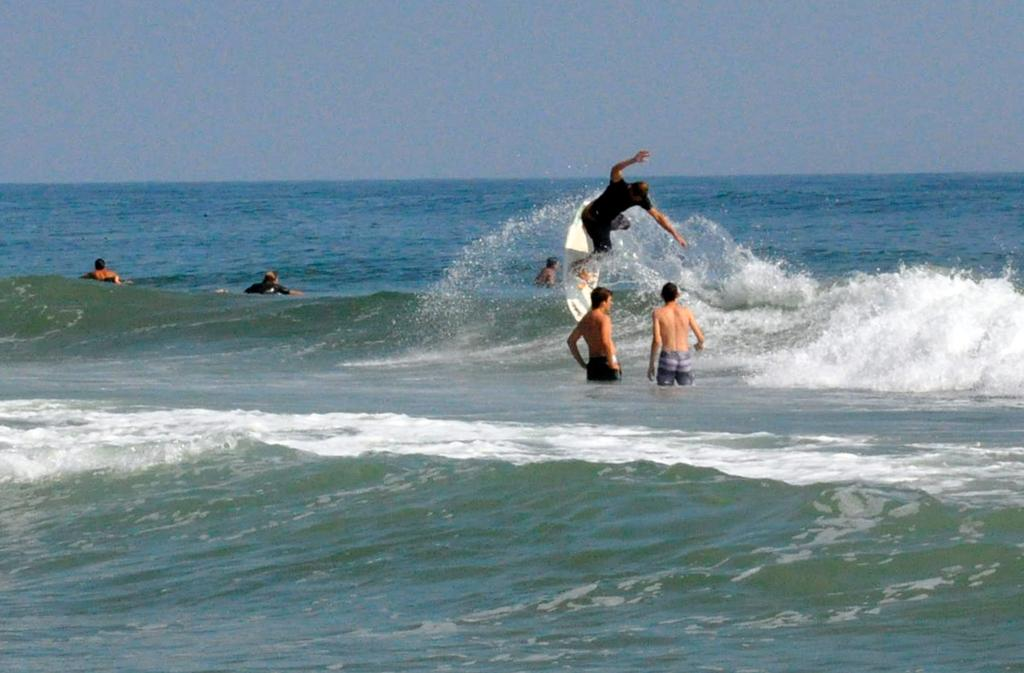What are the people in the image doing? The people in the image are in a large water body. Can you describe the activity of one of the people in the water? One person is surfing in the water using a surfing board. What can be seen above the water in the image? The sky is visible in the image. How would you describe the weather based on the appearance of the sky? The sky appears to be cloudy in the image. How many lizards are sitting on the surfing board in the image? There are no lizards present in the image; it features people in a large water body, with one person surfing using a surfing board. 